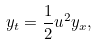<formula> <loc_0><loc_0><loc_500><loc_500>y _ { t } = \frac { 1 } { 2 } u ^ { 2 } y _ { x } ,</formula> 